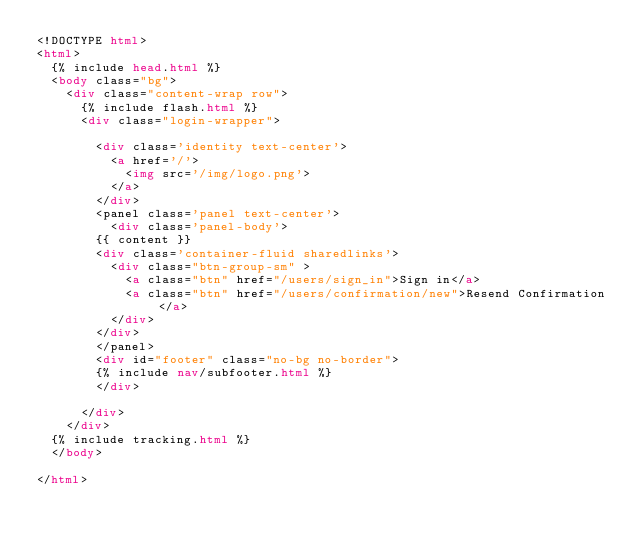Convert code to text. <code><loc_0><loc_0><loc_500><loc_500><_HTML_><!DOCTYPE html>
<html>
  {% include head.html %}
  <body class="bg">
    <div class="content-wrap row">
      {% include flash.html %}
      <div class="login-wrapper">

        <div class='identity text-center'>
          <a href='/'>
            <img src='/img/logo.png'>
          </a>
        </div>
        <panel class='panel text-center'>
          <div class='panel-body'>
        {{ content }}
        <div class='container-fluid sharedlinks'>
          <div class="btn-group-sm" >
            <a class="btn" href="/users/sign_in">Sign in</a>
            <a class="btn" href="/users/confirmation/new">Resend Confirmation</a>
          </div>
        </div>
        </panel>
        <div id="footer" class="no-bg no-border">
        {% include nav/subfooter.html %}
        </div>

      </div>
    </div>
  {% include tracking.html %}
  </body>

</html>
</code> 